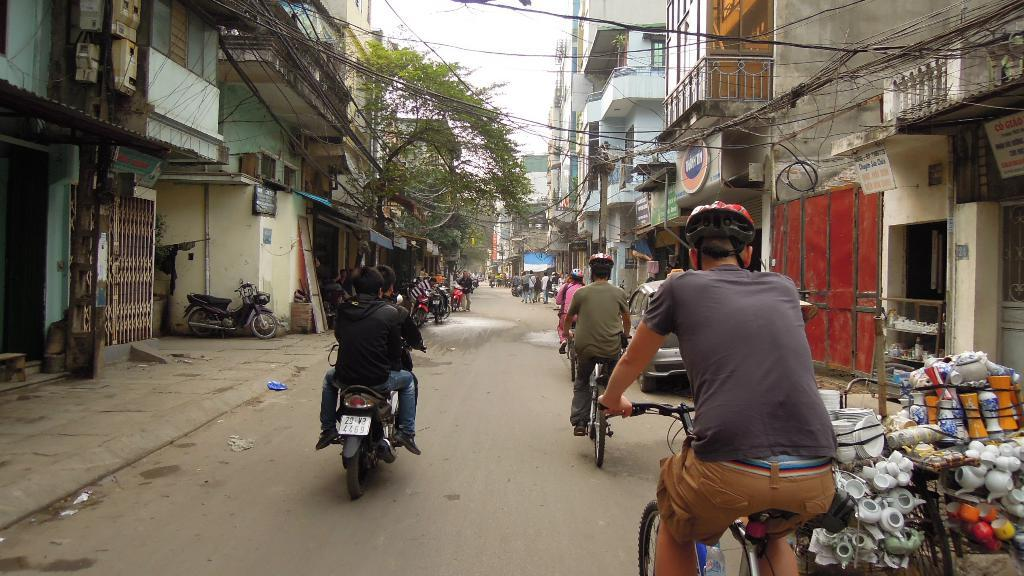What are the people in the image doing? The people in the image are on bicycles. How many persons are on each bike? There are two persons on one bike. What is the setting of the image? The image shows a road. What else can be seen in the background of the image? There are buildings and a tree visible in the image. What is visible above the scene in the image? The sky is visible in the image. What letters are the persons on the bicycles holding in the image? There are no letters visible in the image; the persons are simply riding bicycles. What type of animal can be seen interacting with the persons on the bicycles in the image? There are no animals present in the image; the persons are riding bicycles without any interaction with animals. 